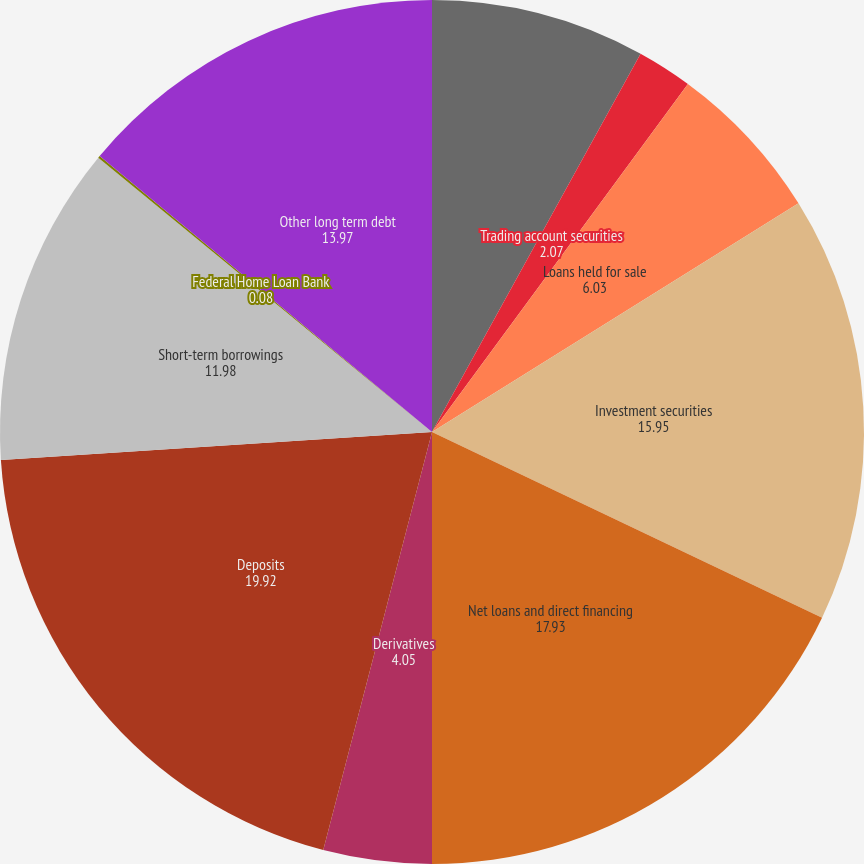<chart> <loc_0><loc_0><loc_500><loc_500><pie_chart><fcel>Cash and short-term assets<fcel>Trading account securities<fcel>Loans held for sale<fcel>Investment securities<fcel>Net loans and direct financing<fcel>Derivatives<fcel>Deposits<fcel>Short-term borrowings<fcel>Federal Home Loan Bank<fcel>Other long term debt<nl><fcel>8.02%<fcel>2.07%<fcel>6.03%<fcel>15.95%<fcel>17.93%<fcel>4.05%<fcel>19.92%<fcel>11.98%<fcel>0.08%<fcel>13.97%<nl></chart> 